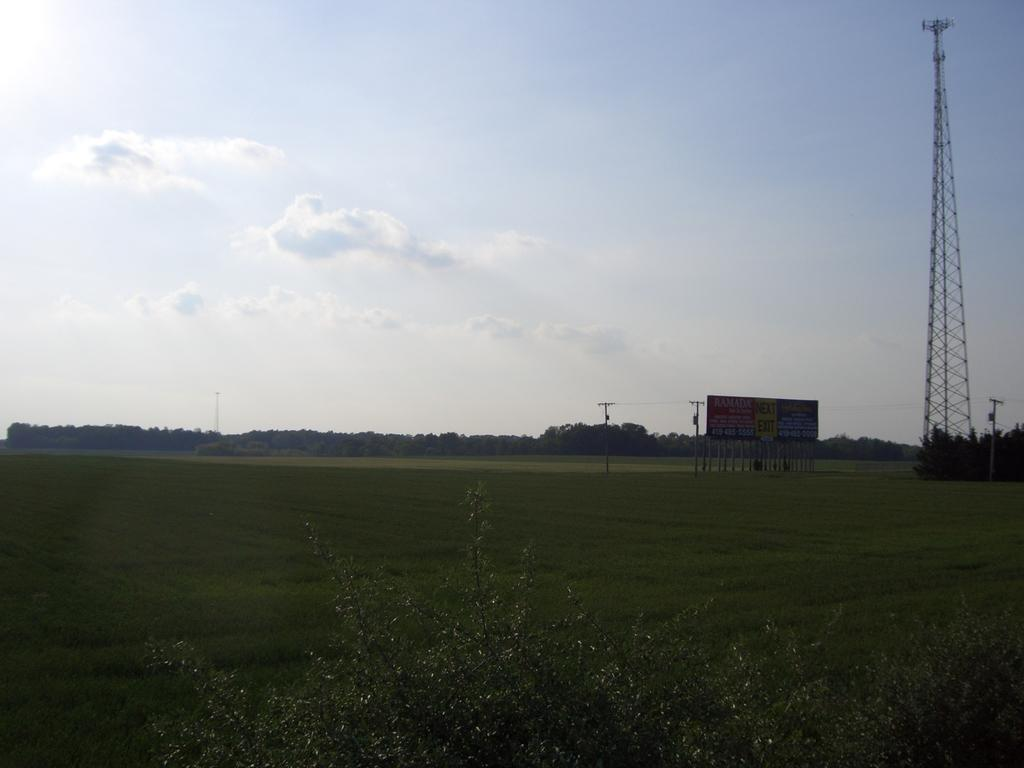What type of living organisms can be seen in the image? Plants and grass are visible in the image. What is the color of the plants and grass in the image? The plants and grass are green in the image. What can be seen in the background of the image? There is a tower and electric poles in the background of the image. What is attached to one of the electric poles? There is a board attached to one of the poles. What is the color of the sky in the image? The sky is white in color. What type of vacation destination is depicted in the image? There is no indication of a vacation destination in the image; it features plants, grass, a tower, electric poles, and a board. What type of wool can be seen on the bear in the image? There is no bear present in the image, so there is no wool to be seen. 